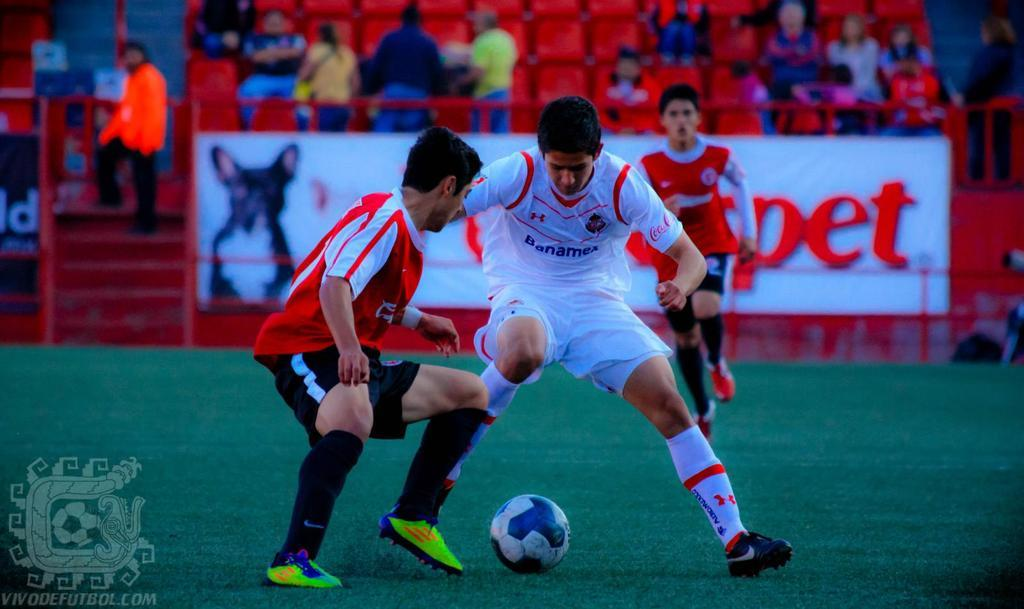Provide a one-sentence caption for the provided image. A man wearing Banamex's jersey is playing soccer with another team. 